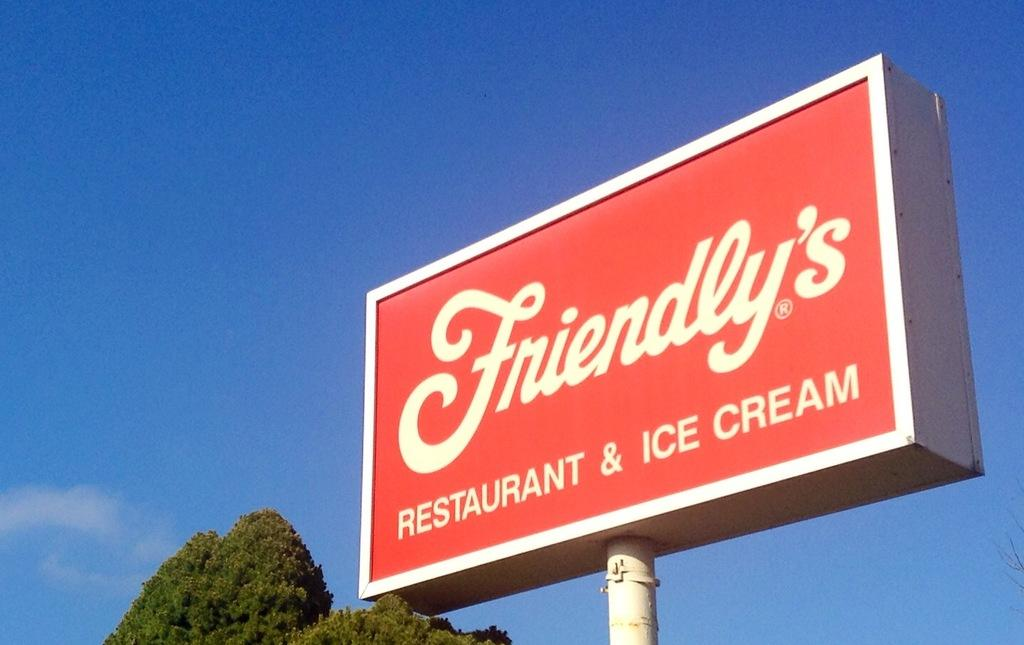Provide a one-sentence caption for the provided image. A big red business sign with white writing saying "Friendly's Restaurant & Ice Cream.". 